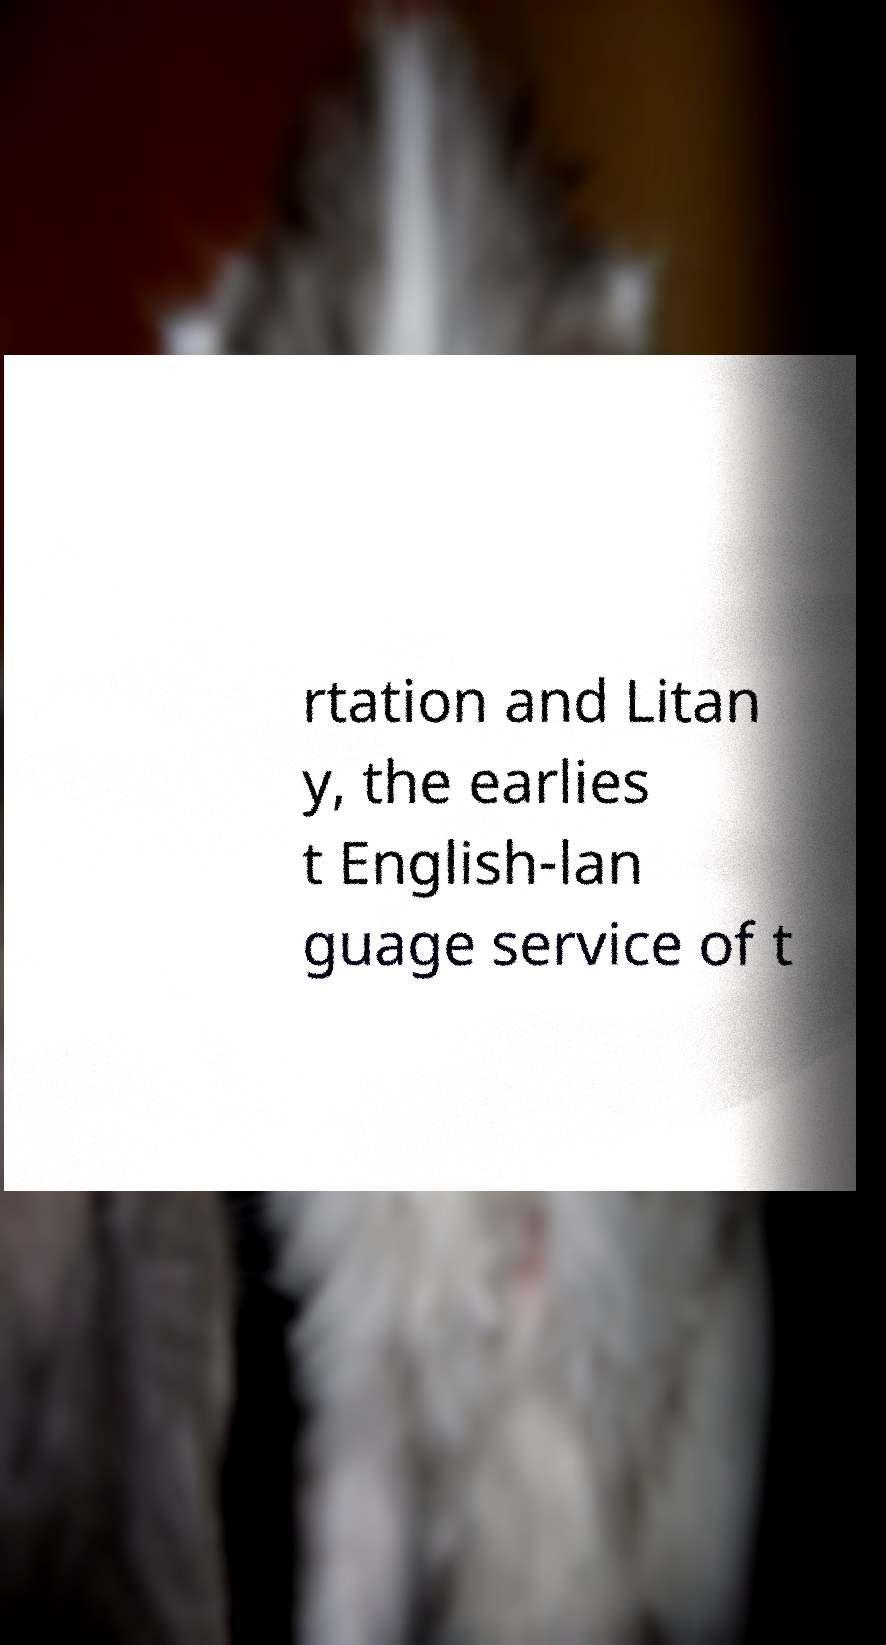Can you read and provide the text displayed in the image?This photo seems to have some interesting text. Can you extract and type it out for me? rtation and Litan y, the earlies t English-lan guage service of t 